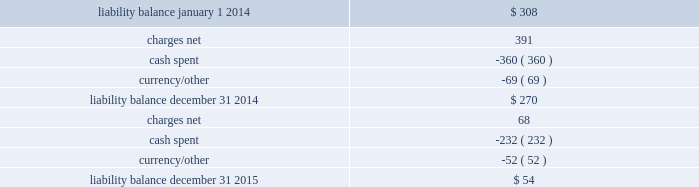Movement in exit cost liabilities the movement in exit cost liabilities for pmi was as follows : ( in millions ) .
Cash payments related to exit costs at pmi were $ 232 million , $ 360 million and $ 21 million for the years ended december 31 , 2015 , 2014 and 2013 , respectively .
Future cash payments for exit costs incurred to date are expected to be approximately $ 54 million , and will be substantially paid by the end of 2017 .
The pre-tax asset impairment and exit costs shown above are primarily a result of the following : the netherlands on april 4 , 2014 , pmi announced the initiation by its affiliate , philip morris holland b.v .
( 201cpmh 201d ) , of consultations with employee representatives on a proposal to discontinue cigarette production at its factory located in bergen op zoom , the netherlands .
Pmh reached an agreement with the trade unions and their members on a social plan and ceased cigarette production on september 1 , 2014 .
During 2014 , total pre-tax asset impairment and exit costs of $ 489 million were recorded for this program in the european union segment .
This amount includes employee separation costs of $ 343 million , asset impairment costs of $ 139 million and other separation costs of $ 7 million .
Separation program charges pmi recorded other pre-tax separation program charges of $ 68 million , $ 41 million and $ 51 million for the years ended december 31 , 2015 , 2014 and 2013 , respectively .
The 2015 other pre-tax separation program charges primarily related to severance costs for the organizational restructuring in the european union segment .
The 2014 other pre-tax separation program charges primarily related to severance costs for factory closures in australia and canada and the restructuring of the u.s .
Leaf purchasing model .
The 2013 pre-tax separation program charges primarily related to the restructuring of global and regional functions based in switzerland and australia .
Contract termination charges during 2013 , pmi recorded exit costs of $ 258 million related to the termination of distribution agreements in eastern europe , middle east & africa ( due to a new business model in egypt ) and asia .
Asset impairment charges during 2014 , pmi recorded other pre-tax asset impairment charges of $ 5 million related to a factory closure in canada. .
What is the change in liability balance during 2014? 
Computations: (270 - 308)
Answer: -38.0. 